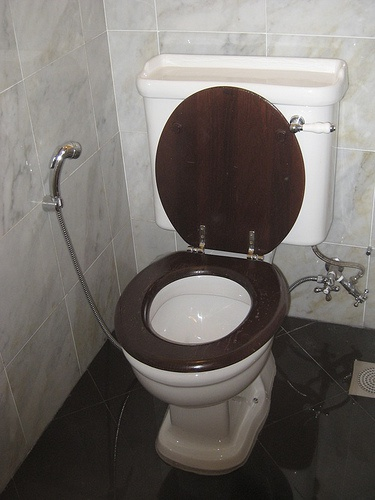Describe the objects in this image and their specific colors. I can see a toilet in darkgray, black, lightgray, and gray tones in this image. 